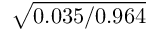Convert formula to latex. <formula><loc_0><loc_0><loc_500><loc_500>\sqrt { 0 . 0 3 5 / 0 . 9 6 4 }</formula> 